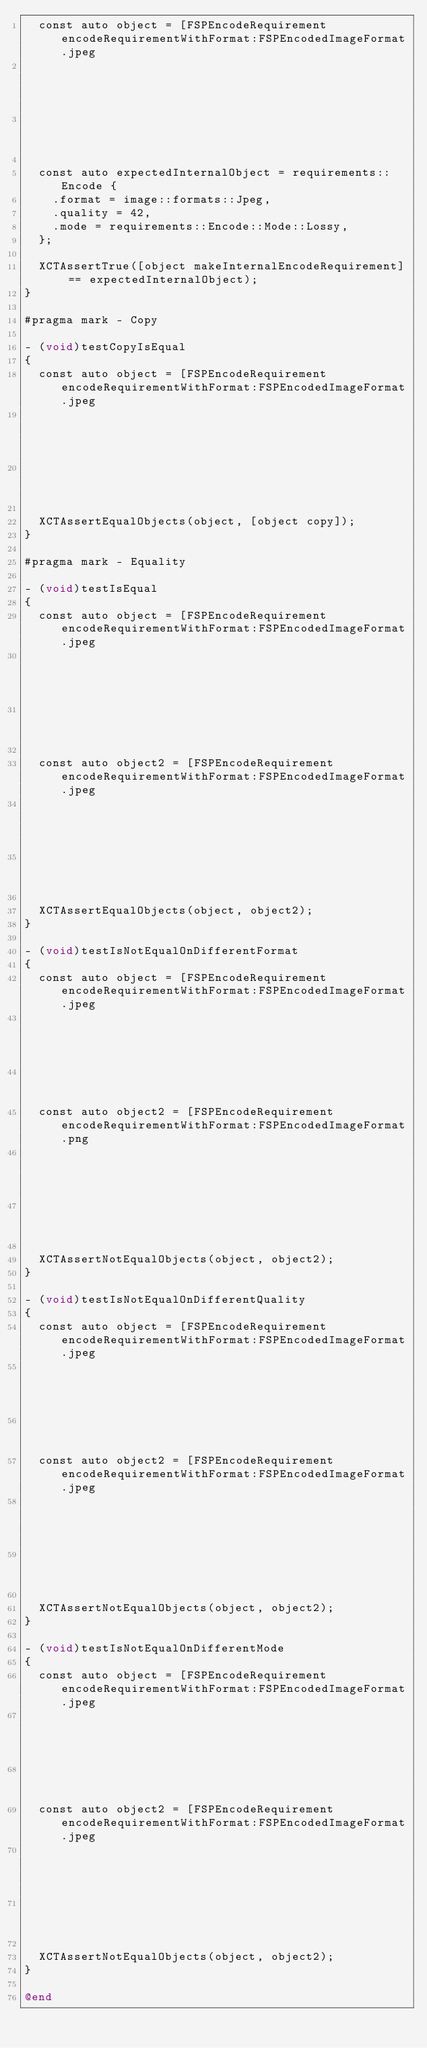<code> <loc_0><loc_0><loc_500><loc_500><_ObjectiveC_>  const auto object = [FSPEncodeRequirement encodeRequirementWithFormat:FSPEncodedImageFormat.jpeg
                                                                   mode:FSPEncodeRequirementModeLossy
                                                                quality:42];

  const auto expectedInternalObject = requirements::Encode {
    .format = image::formats::Jpeg,
    .quality = 42,
    .mode = requirements::Encode::Mode::Lossy,
  };

  XCTAssertTrue([object makeInternalEncodeRequirement] == expectedInternalObject);
}

#pragma mark - Copy

- (void)testCopyIsEqual
{
  const auto object = [FSPEncodeRequirement encodeRequirementWithFormat:FSPEncodedImageFormat.jpeg
                                                                   mode:FSPEncodeRequirementModeLossy
                                                                quality:42];

  XCTAssertEqualObjects(object, [object copy]);
}

#pragma mark - Equality

- (void)testIsEqual
{
  const auto object = [FSPEncodeRequirement encodeRequirementWithFormat:FSPEncodedImageFormat.jpeg
                                                                   mode:FSPEncodeRequirementModeLossy
                                                                quality:42];

  const auto object2 = [FSPEncodeRequirement encodeRequirementWithFormat:FSPEncodedImageFormat.jpeg
                                                                    mode:FSPEncodeRequirementModeLossy
                                                                 quality:42];

  XCTAssertEqualObjects(object, object2);
}

- (void)testIsNotEqualOnDifferentFormat
{
  const auto object = [FSPEncodeRequirement encodeRequirementWithFormat:FSPEncodedImageFormat.jpeg
                                                                   mode:FSPEncodeRequirementModeLossy
                                                                quality:42];
  const auto object2 = [FSPEncodeRequirement encodeRequirementWithFormat:FSPEncodedImageFormat.png
                                                                   mode:FSPEncodeRequirementModeLossy
                                                                quality:42];

  XCTAssertNotEqualObjects(object, object2);
}

- (void)testIsNotEqualOnDifferentQuality
{
  const auto object = [FSPEncodeRequirement encodeRequirementWithFormat:FSPEncodedImageFormat.jpeg
                                                                   mode:FSPEncodeRequirementModeLossy
                                                                quality:42];
  const auto object2 = [FSPEncodeRequirement encodeRequirementWithFormat:FSPEncodedImageFormat.jpeg
                                                                    mode:FSPEncodeRequirementModeLossy
                                                                 quality:43];

  XCTAssertNotEqualObjects(object, object2);
}

- (void)testIsNotEqualOnDifferentMode
{
  const auto object = [FSPEncodeRequirement encodeRequirementWithFormat:FSPEncodedImageFormat.jpeg
                                                                   mode:FSPEncodeRequirementModeLossy
                                                                quality:42];
  const auto object2 = [FSPEncodeRequirement encodeRequirementWithFormat:FSPEncodedImageFormat.jpeg
                                                                    mode:FSPEncodeRequirementModeLossless
                                                                 quality:42];

  XCTAssertNotEqualObjects(object, object2);
}

@end
</code> 